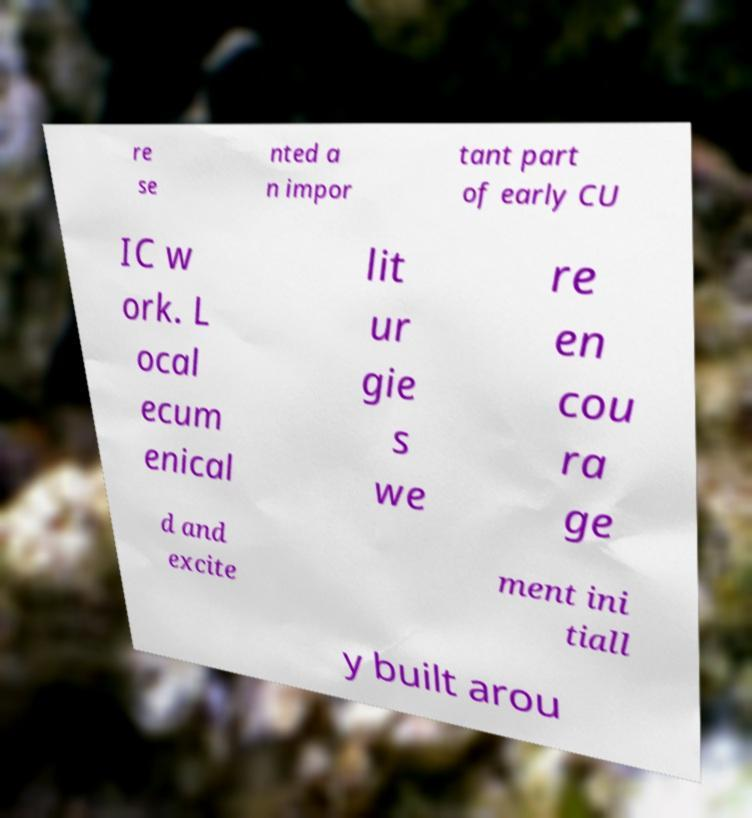Please identify and transcribe the text found in this image. re se nted a n impor tant part of early CU IC w ork. L ocal ecum enical lit ur gie s we re en cou ra ge d and excite ment ini tiall y built arou 